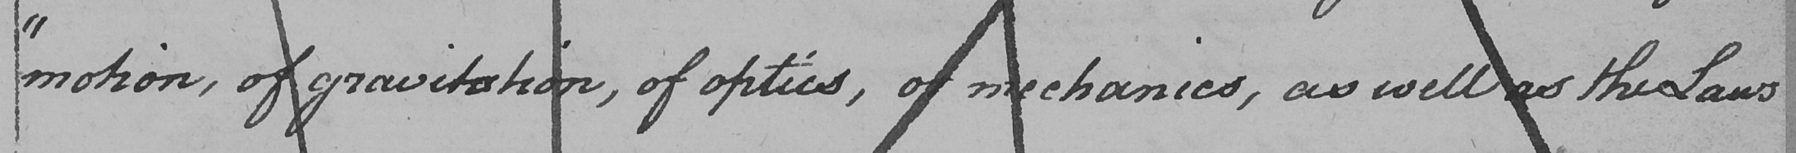What is written in this line of handwriting? " motion , of gravitation , of optics , of mechanics , as well as the Laws 